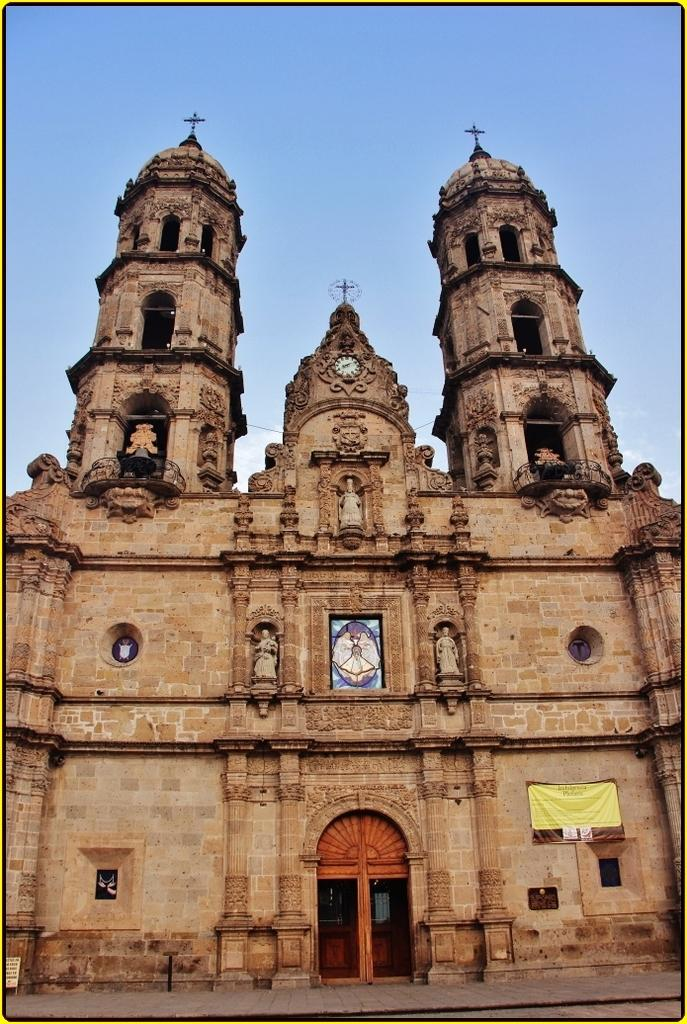What type of structure is depicted in the image? There is an ancient architecture in the image. What additional element can be seen in the image? There is a banner in the image. What other objects are present in the image? There are statues and a clock in the image. What can be seen in the background of the image? The sky is visible in the background of the image. How does the beginner use the comb in the image? There is no beginner or comb present in the image. What type of boat can be seen in the image? There is no boat present in the image. 